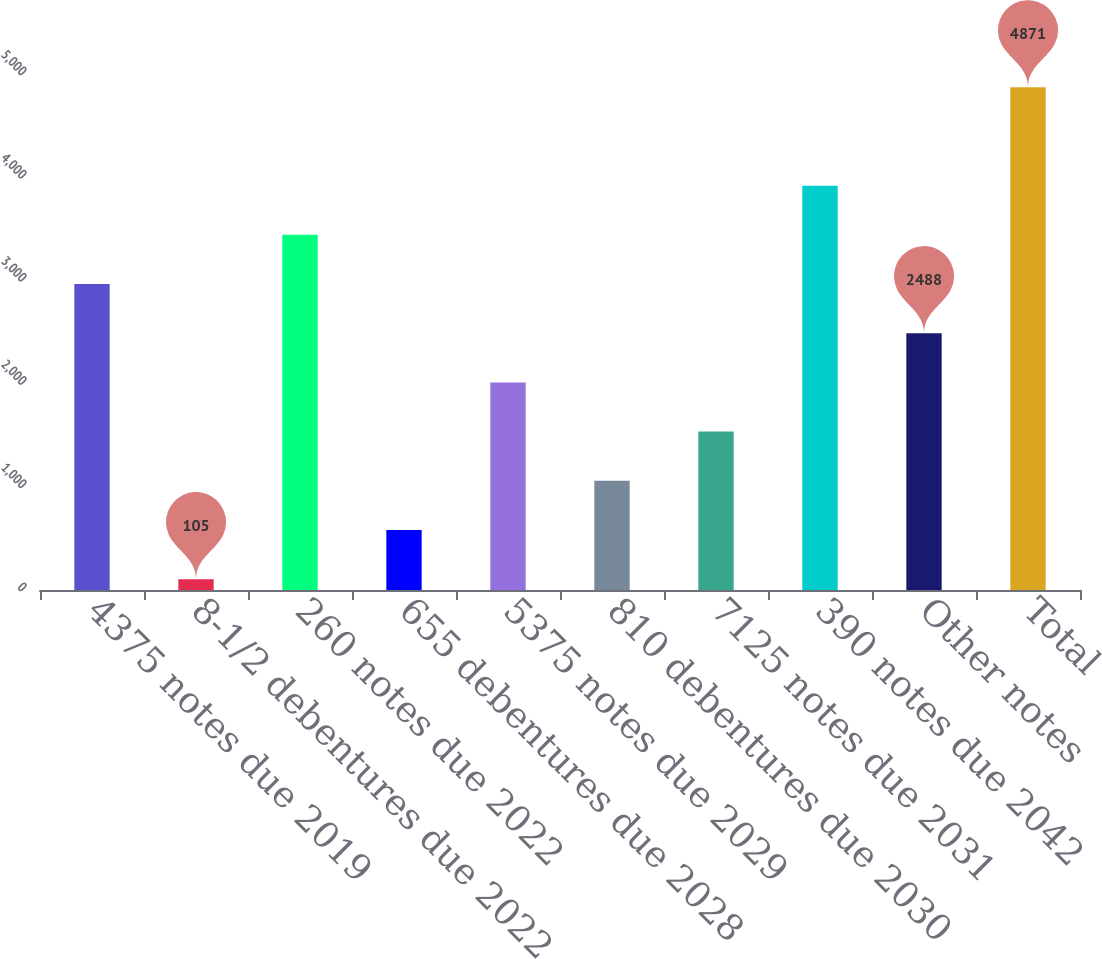Convert chart to OTSL. <chart><loc_0><loc_0><loc_500><loc_500><bar_chart><fcel>4375 notes due 2019<fcel>8-1/2 debentures due 2022<fcel>260 notes due 2022<fcel>655 debentures due 2028<fcel>5375 notes due 2029<fcel>810 debentures due 2030<fcel>7125 notes due 2031<fcel>390 notes due 2042<fcel>Other notes<fcel>Total<nl><fcel>2964.6<fcel>105<fcel>3441.2<fcel>581.6<fcel>2011.4<fcel>1058.2<fcel>1534.8<fcel>3917.8<fcel>2488<fcel>4871<nl></chart> 